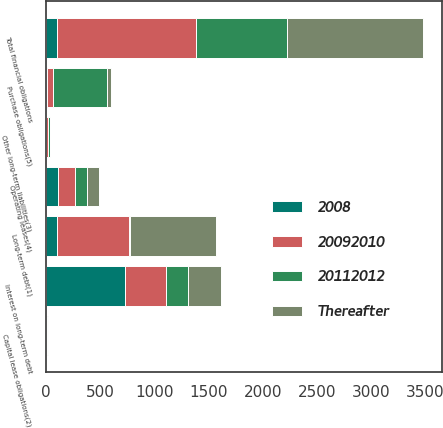<chart> <loc_0><loc_0><loc_500><loc_500><stacked_bar_chart><ecel><fcel>Long-term debt(1)<fcel>Interest on long-term debt<fcel>Capital lease obligations(2)<fcel>Other long-term liabilities(3)<fcel>Operating leases(4)<fcel>Purchase obligations(5)<fcel>Total financial obligations<nl><fcel>20112012<fcel>13.1<fcel>202<fcel>3.7<fcel>14.9<fcel>105.2<fcel>499.4<fcel>838.3<nl><fcel>20092010<fcel>655<fcel>376<fcel>6.4<fcel>21<fcel>159.4<fcel>58.9<fcel>1276.7<nl><fcel>Thereafter<fcel>789.4<fcel>302.2<fcel>5.4<fcel>7.2<fcel>113.1<fcel>36<fcel>1253.3<nl><fcel>2008<fcel>109.15<fcel>732.5<fcel>4<fcel>0.1<fcel>114<fcel>10.5<fcel>109.15<nl></chart> 